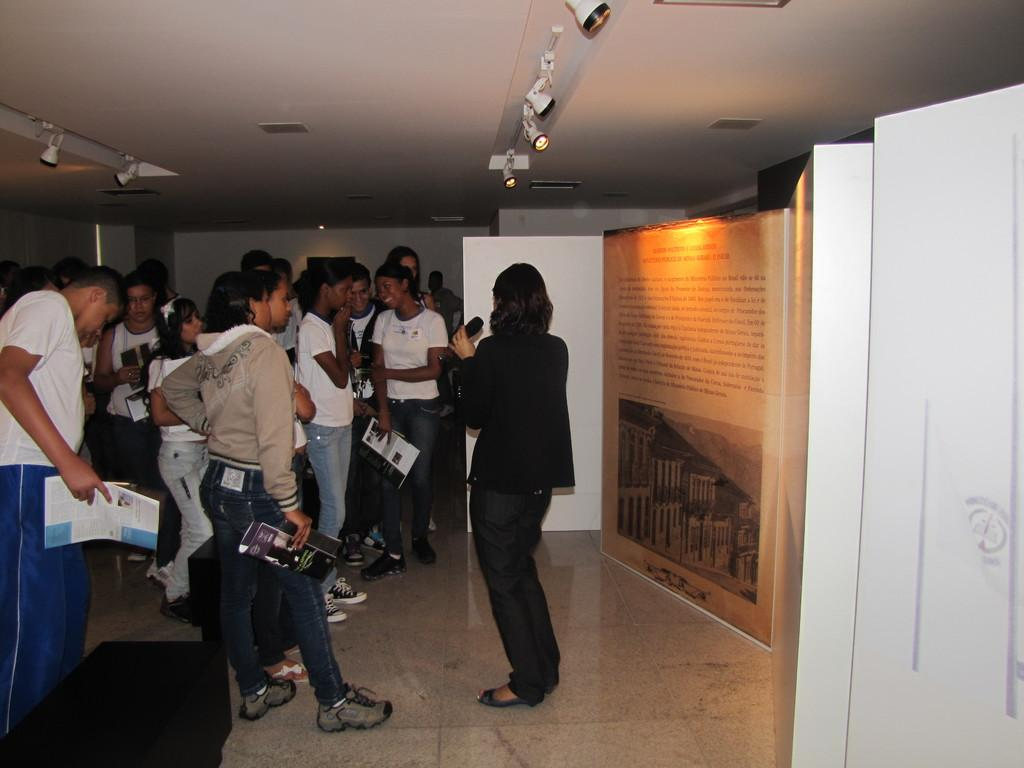What can be seen on the left side of the image? There is a group of people on the left side of the image. What is visible at the top of the image? There are lights visible at the top of the image. How many visitors are present in the cellar in the image? There is no mention of a cellar or visitors in the image; it only shows a group of people on the left side and lights at the top. 